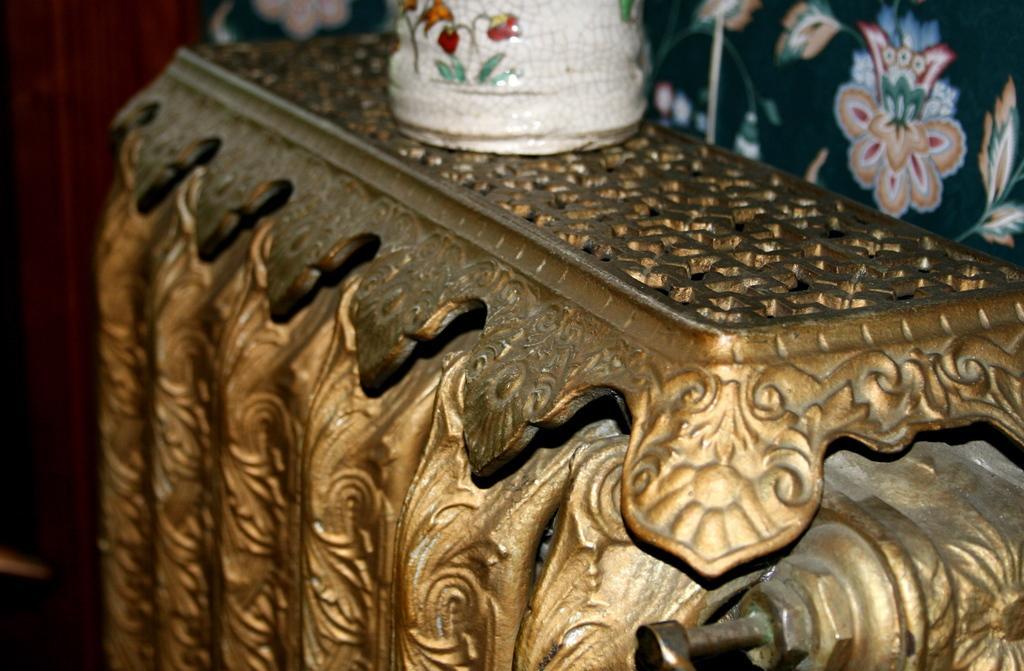Please provide a concise description of this image. In this image we can see designed objects. 